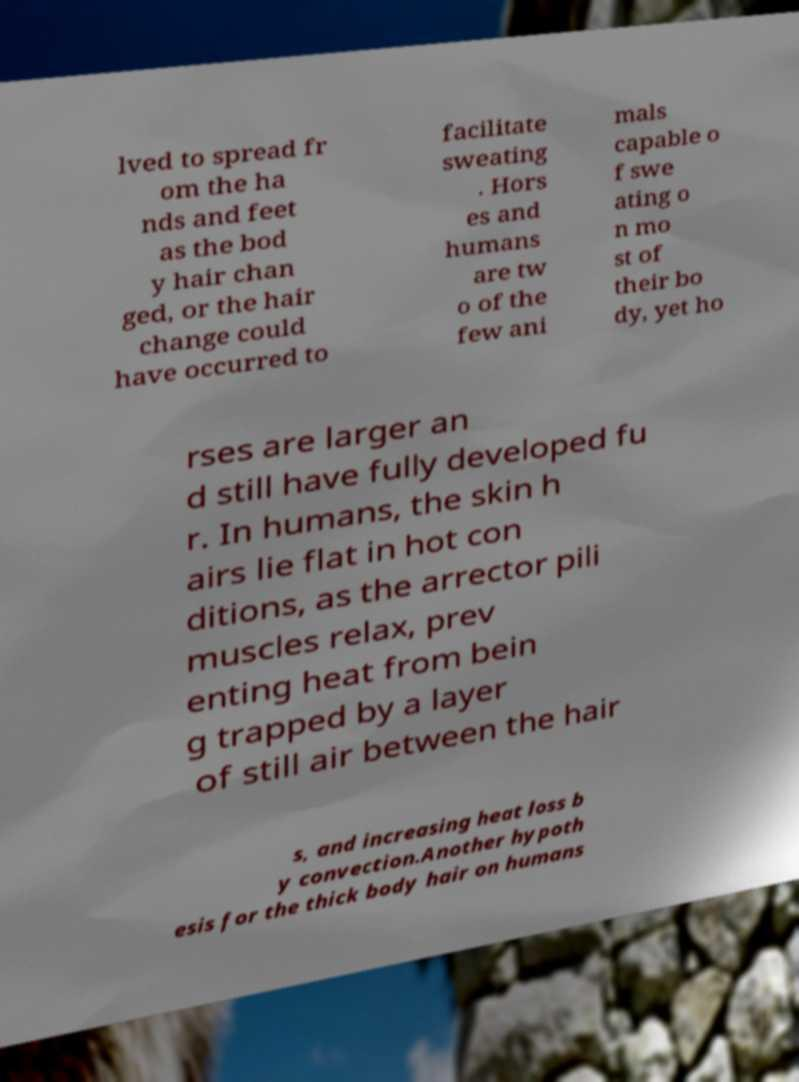For documentation purposes, I need the text within this image transcribed. Could you provide that? lved to spread fr om the ha nds and feet as the bod y hair chan ged, or the hair change could have occurred to facilitate sweating . Hors es and humans are tw o of the few ani mals capable o f swe ating o n mo st of their bo dy, yet ho rses are larger an d still have fully developed fu r. In humans, the skin h airs lie flat in hot con ditions, as the arrector pili muscles relax, prev enting heat from bein g trapped by a layer of still air between the hair s, and increasing heat loss b y convection.Another hypoth esis for the thick body hair on humans 